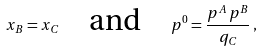Convert formula to latex. <formula><loc_0><loc_0><loc_500><loc_500>x _ { B } = x _ { C } \quad \text {and} \quad p ^ { 0 } = \frac { p ^ { A } \, p ^ { B } } { q _ { C } } \, ,</formula> 